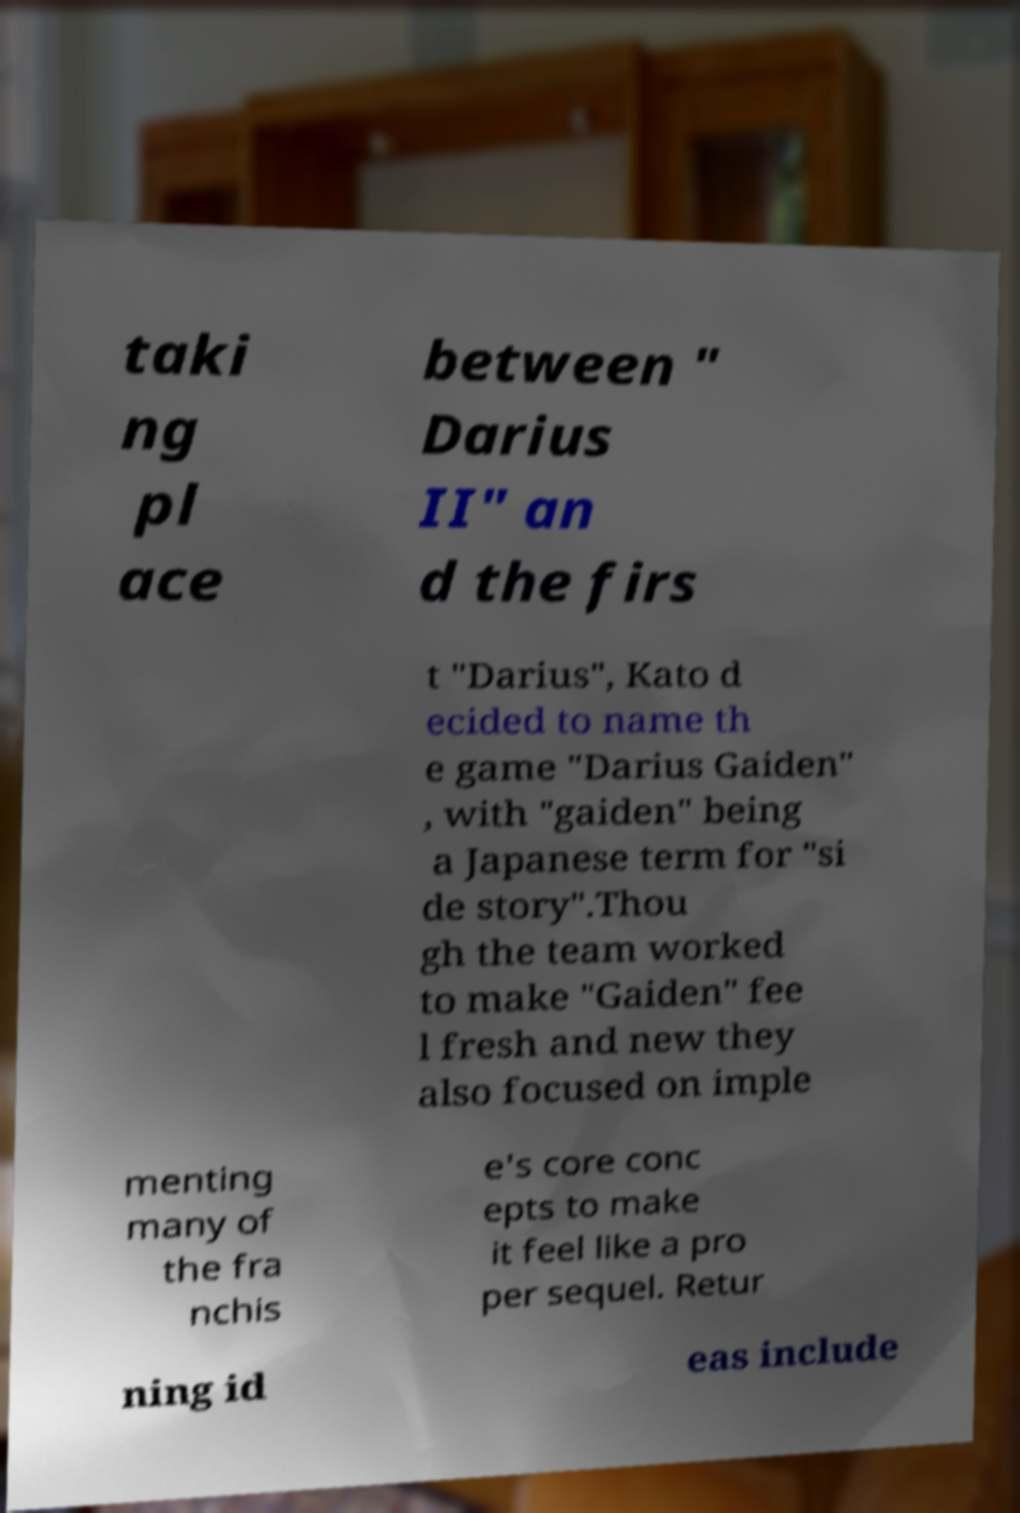What messages or text are displayed in this image? I need them in a readable, typed format. taki ng pl ace between " Darius II" an d the firs t "Darius", Kato d ecided to name th e game "Darius Gaiden" , with "gaiden" being a Japanese term for "si de story".Thou gh the team worked to make "Gaiden" fee l fresh and new they also focused on imple menting many of the fra nchis e's core conc epts to make it feel like a pro per sequel. Retur ning id eas include 